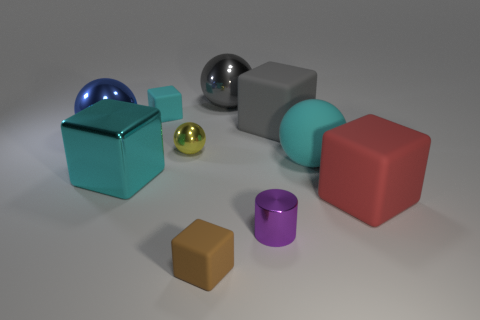What number of other objects are the same shape as the brown object?
Offer a terse response. 4. How many objects are matte cubes to the left of the cylinder or small rubber blocks that are in front of the blue ball?
Give a very brief answer. 2. There is a cyan thing that is both on the left side of the small metal cylinder and in front of the blue metallic object; what is its size?
Offer a terse response. Large. There is a small shiny thing that is left of the gray ball; does it have the same shape as the large gray shiny object?
Make the answer very short. Yes. How big is the cyan matte object in front of the big metal ball to the left of the gray thing that is to the left of the purple object?
Your response must be concise. Large. What is the size of the shiny cube that is the same color as the matte sphere?
Keep it short and to the point. Large. What number of objects are either large red blocks or gray things?
Keep it short and to the point. 3. There is a cyan object that is both left of the small cylinder and right of the shiny block; what shape is it?
Offer a terse response. Cube. Is the shape of the yellow metallic object the same as the big gray object behind the big gray block?
Offer a very short reply. Yes. Are there any large cyan rubber objects in front of the large cyan cube?
Provide a short and direct response. No. 